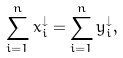<formula> <loc_0><loc_0><loc_500><loc_500>\sum _ { i = 1 } ^ { n } x _ { i } ^ { \downarrow } = \sum _ { i = 1 } ^ { n } y _ { i } ^ { \downarrow } ,</formula> 